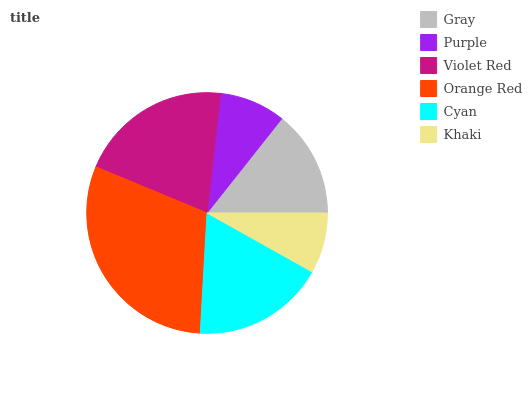Is Khaki the minimum?
Answer yes or no. Yes. Is Orange Red the maximum?
Answer yes or no. Yes. Is Purple the minimum?
Answer yes or no. No. Is Purple the maximum?
Answer yes or no. No. Is Gray greater than Purple?
Answer yes or no. Yes. Is Purple less than Gray?
Answer yes or no. Yes. Is Purple greater than Gray?
Answer yes or no. No. Is Gray less than Purple?
Answer yes or no. No. Is Cyan the high median?
Answer yes or no. Yes. Is Gray the low median?
Answer yes or no. Yes. Is Khaki the high median?
Answer yes or no. No. Is Khaki the low median?
Answer yes or no. No. 